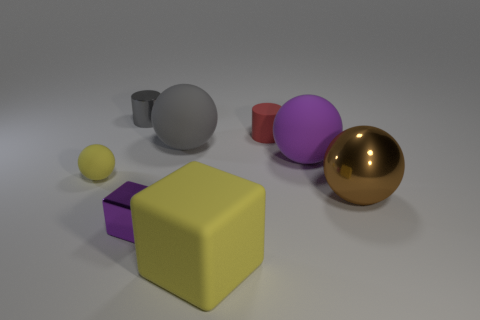What number of other things are the same color as the shiny cube?
Make the answer very short. 1. The metallic block has what color?
Offer a very short reply. Purple. There is a shiny thing that is left of the big gray sphere and behind the purple shiny object; what size is it?
Provide a succinct answer. Small. How many things are metal objects that are in front of the tiny gray cylinder or yellow things?
Ensure brevity in your answer.  4. What is the shape of the small purple thing that is the same material as the brown object?
Provide a short and direct response. Cube. What shape is the red matte object?
Your answer should be very brief. Cylinder. There is a ball that is left of the purple sphere and right of the tiny cube; what is its color?
Your response must be concise. Gray. What shape is the shiny object that is the same size as the rubber cube?
Offer a very short reply. Sphere. Are there any large yellow things of the same shape as the tiny red thing?
Offer a very short reply. No. Is the material of the large purple object the same as the small cylinder that is behind the tiny red cylinder?
Provide a short and direct response. No. 